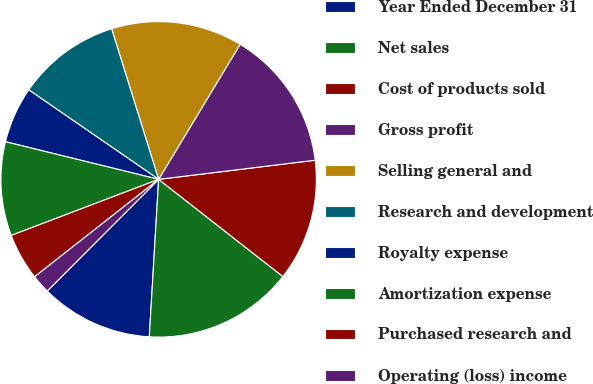Convert chart to OTSL. <chart><loc_0><loc_0><loc_500><loc_500><pie_chart><fcel>Year Ended December 31<fcel>Net sales<fcel>Cost of products sold<fcel>Gross profit<fcel>Selling general and<fcel>Research and development<fcel>Royalty expense<fcel>Amortization expense<fcel>Purchased research and<fcel>Operating (loss) income<nl><fcel>11.54%<fcel>15.38%<fcel>12.5%<fcel>14.42%<fcel>13.46%<fcel>10.58%<fcel>5.77%<fcel>9.62%<fcel>4.81%<fcel>1.92%<nl></chart> 